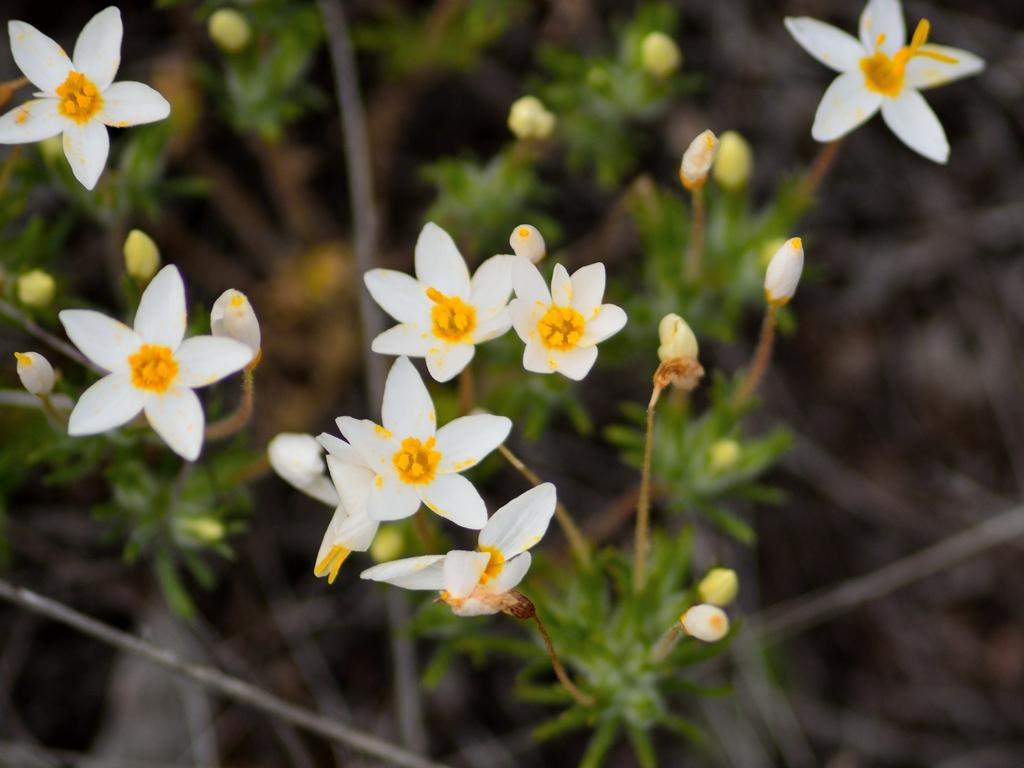Describe this image in one or two sentences. In this picture, we see plants which have flowers and buds. These flowers are in white color. In the background, it is blurred. 